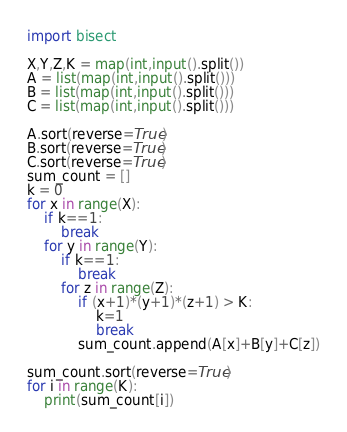Convert code to text. <code><loc_0><loc_0><loc_500><loc_500><_Python_>import bisect

X,Y,Z,K = map(int,input().split())
A = list(map(int,input().split()))
B = list(map(int,input().split()))
C = list(map(int,input().split()))

A.sort(reverse=True)
B.sort(reverse=True)
C.sort(reverse=True)
sum_count = []
k = 0
for x in range(X):
    if k==1:
        break
    for y in range(Y):
        if k==1:
            break
        for z in range(Z):
            if (x+1)*(y+1)*(z+1) > K:
                k=1
                break
            sum_count.append(A[x]+B[y]+C[z])

sum_count.sort(reverse=True)
for i in range(K):
    print(sum_count[i])</code> 